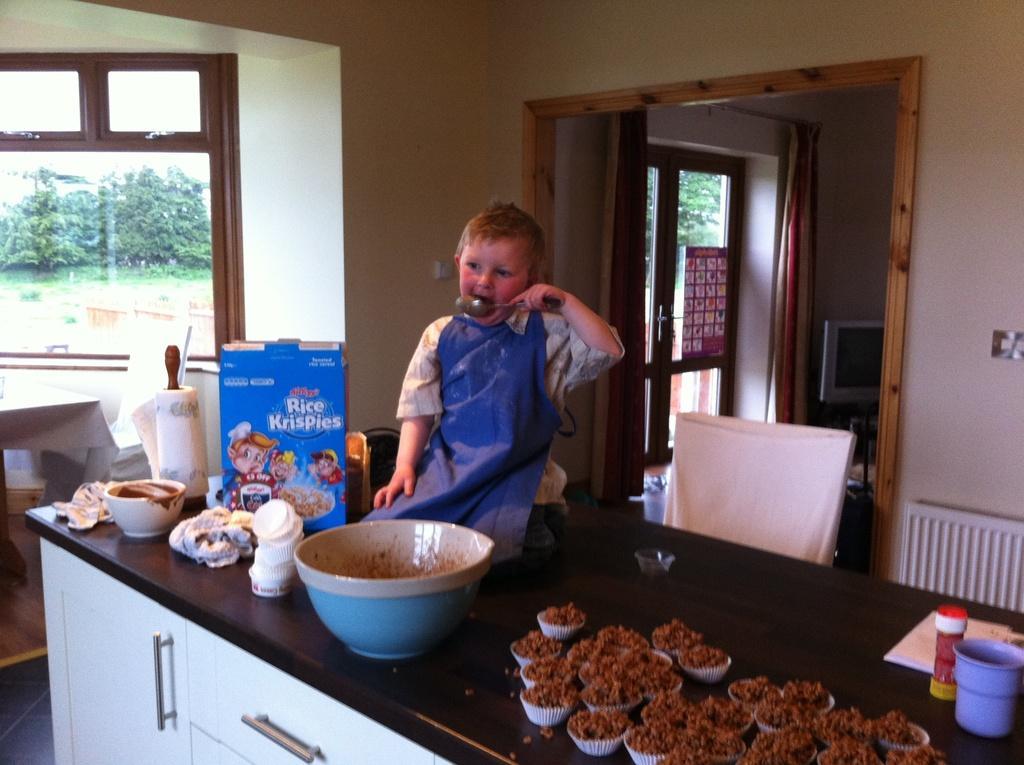Please provide a concise description of this image. In the center of the image we can see one table, drawer and cupboard. On the table, we can see one kid is sitting and holding some object. And we can see bowls, one box, one cloth, one cup, cupcakes, some food items and a few other objects. In the background there is a wall, glass, curtain, monitor, poster, chair and a few other objects. Through the glass, we can see trees. 